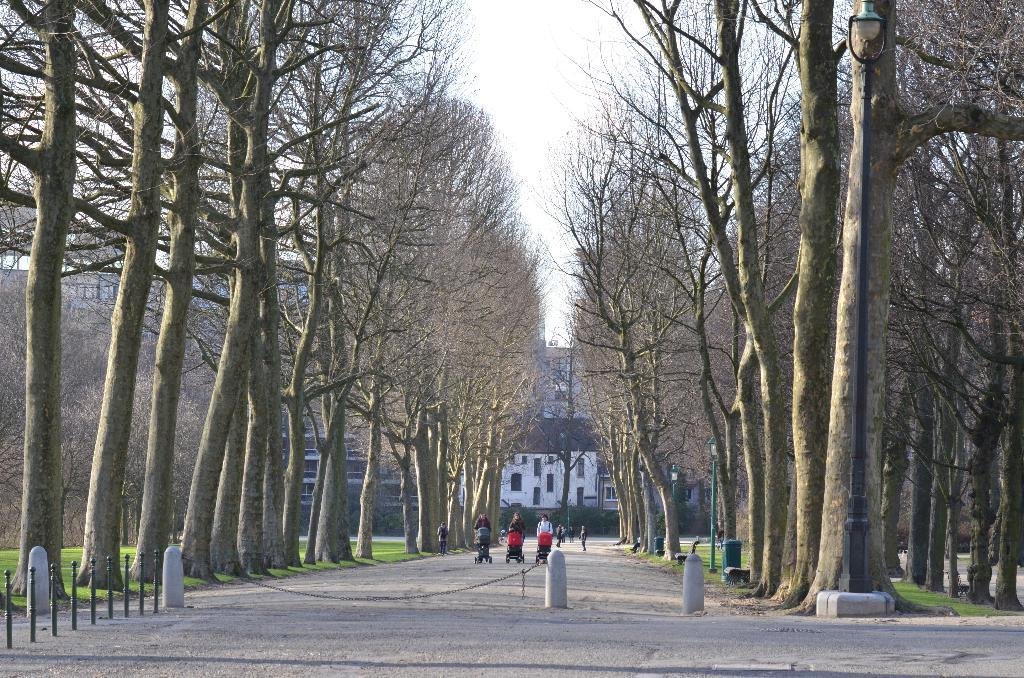What is happening on the road in the image? There are people on the road in the image. What type of vegetation is visible beside the people? There are bare trees beside the people. What can be seen in the distance in the image? There are buildings with windows in the distance. What type of structures are providing light in the image? There are light poles visible in the image. How many dresses are being worn by the people in the image? There is no information about dresses or clothing in the image, so we cannot determine how many dresses are being worn. What act are the people performing on the road in the image? There is no indication of a specific act or performance being carried out by the people in the image; they are simply on the road. 